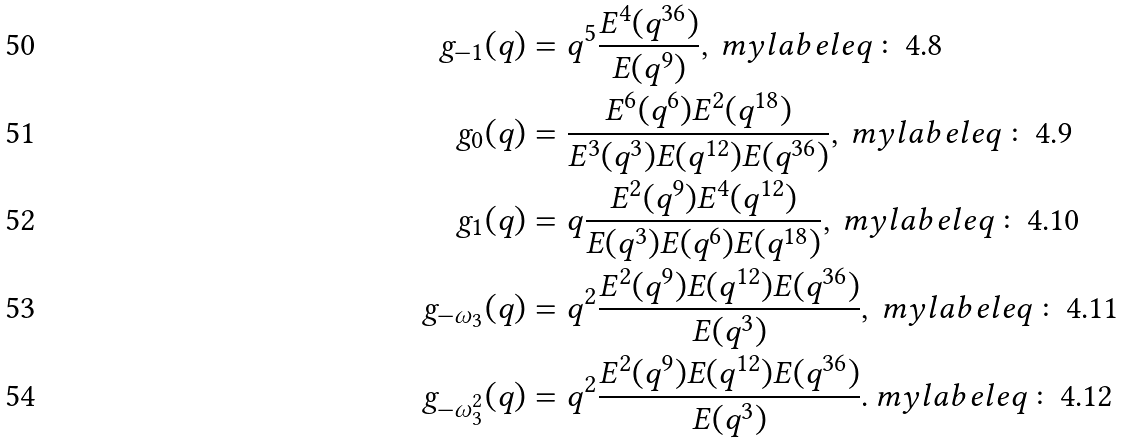<formula> <loc_0><loc_0><loc_500><loc_500>g _ { - 1 } ( q ) & = q ^ { 5 } \frac { E ^ { 4 } ( q ^ { 3 6 } ) } { E ( q ^ { 9 } ) } , \ m y l a b e l { e q \colon 4 . 8 } \\ g _ { 0 } ( q ) & = \frac { E ^ { 6 } ( q ^ { 6 } ) E ^ { 2 } ( q ^ { 1 8 } ) } { E ^ { 3 } ( q ^ { 3 } ) E ( q ^ { 1 2 } ) E ( q ^ { 3 6 } ) } , \ m y l a b e l { e q \colon 4 . 9 } \\ g _ { 1 } ( q ) & = q \frac { E ^ { 2 } ( q ^ { 9 } ) E ^ { 4 } ( q ^ { 1 2 } ) } { E ( q ^ { 3 } ) E ( q ^ { 6 } ) E ( q ^ { 1 8 } ) } , \ m y l a b e l { e q \colon 4 . 1 0 } \\ g _ { - \omega _ { 3 } } ( q ) & = q ^ { 2 } \frac { E ^ { 2 } ( q ^ { 9 } ) E ( q ^ { 1 2 } ) E ( q ^ { 3 6 } ) } { E ( q ^ { 3 } ) } , \ m y l a b e l { e q \colon 4 . 1 1 } \\ g _ { - \omega _ { 3 } ^ { 2 } } ( q ) & = q ^ { 2 } \frac { E ^ { 2 } ( q ^ { 9 } ) E ( q ^ { 1 2 } ) E ( q ^ { 3 6 } ) } { E ( q ^ { 3 } ) } . \ m y l a b e l { e q \colon 4 . 1 2 }</formula> 